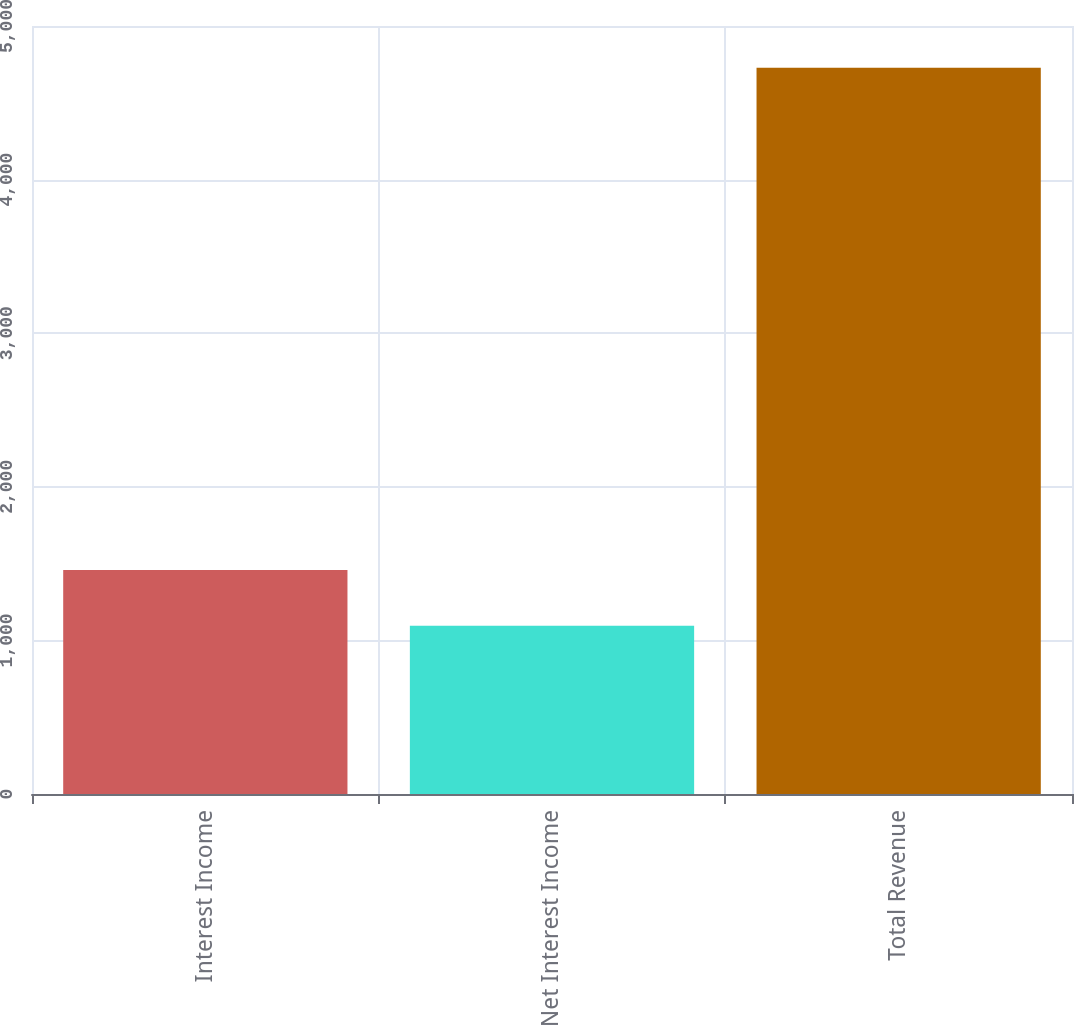Convert chart. <chart><loc_0><loc_0><loc_500><loc_500><bar_chart><fcel>Interest Income<fcel>Net Interest Income<fcel>Total Revenue<nl><fcel>1458.65<fcel>1095.4<fcel>4727.9<nl></chart> 